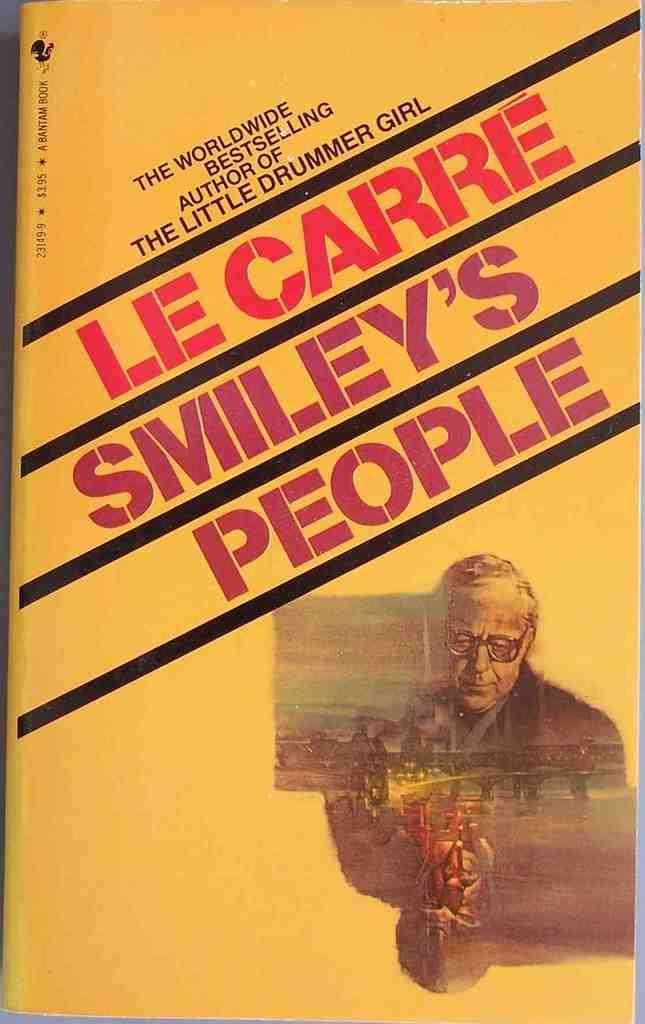<image>
Give a short and clear explanation of the subsequent image. Le Carre's Smiley's People feature a yellow cover with a man on front 